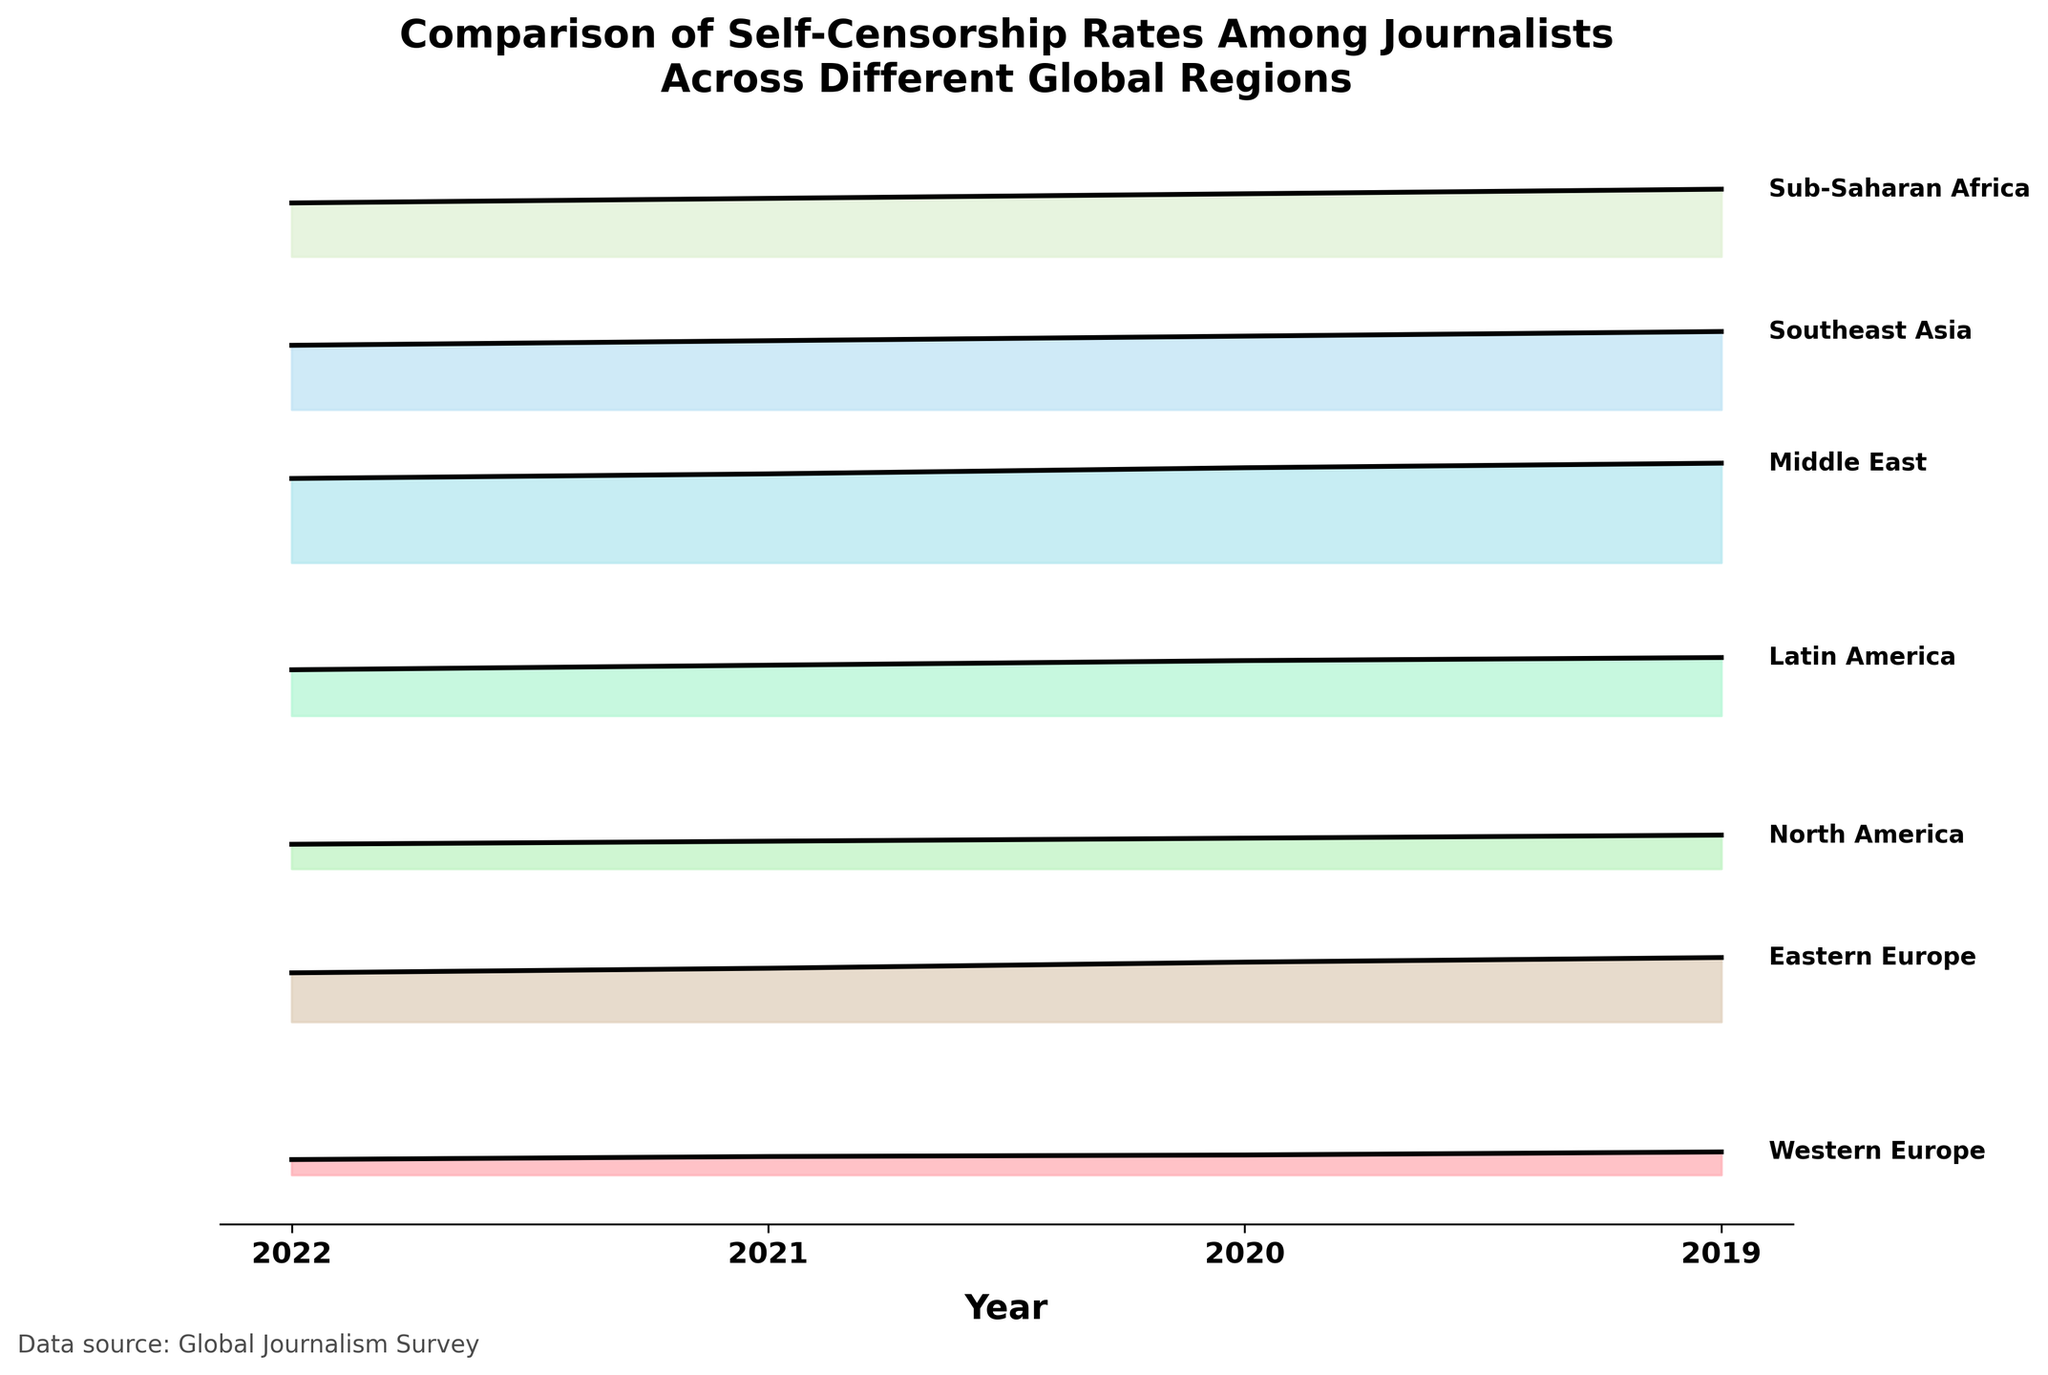what is the title of the figure? The title is usually found at the top of the figure. Here it says "Comparison of Self-Censorship Rates Among Journalists Across Different Global Regions."
Answer: Comparison of Self-Censorship Rates Among Journalists Across Different Global Regions How many years of data are displayed in the plot? The x-axis labels show the years. Counting these labels will give the number of years displayed. The years shown are 2019, 2020, 2021, and 2022.
Answer: 4 Which region has the highest self-censorship rate in 2022? Looking at the highest point in 2022 on the right side of the plot, the color-coded ridgeline with the highest elevation represents the Middle East.
Answer: Middle East How does the self-censorship rate in Western Europe change from 2019 to 2022? Following the ridgeline for Western Europe, the self-censorship rate starts at 0.10 in 2019 and increases each year to 0.15 in 2022.
Answer: It increases Which regions show an increasing trend in self-censorship rate over the years? Observing the slopes of the ridgelines, Western Europe, North America, Latin America, Southeast Asia, and Sub-Saharan Africa show increasing trends as their rates rise year by year.
Answer: Western Europe, North America, Latin America, Southeast Asia, Sub-Saharan Africa Which region has the highest self-censorship rate overall across all years? The plot shows different color-coded ridgelines. The Middle East consistently has the highest elevation throughout the years from 2019 to 2022, indicating the highest self-censorship rates.
Answer: Middle East Between North America and Eastern Europe in 2019, which has a higher self-censorship rate? Check the ridgelines for North America and Eastern Europe at the position corresponding to 2019. North America's rate is lower at 0.16, while Eastern Europe's rate is higher at 0.32.
Answer: Eastern Europe What is the overall trend in self-censorship rates for Southeast Asia from 2019 to 2022? Following the ridgeline for Southeast Asia, the self-censorship rate increases steadily from 0.42 in 2019 to 0.51 in 2022.
Answer: Increasing Which region had the most significant increase in self-censorship rate from 2019 to 2022? Calculating the difference in rates between 2019 and 2022 for all regions, the Middle East increased from 0.55 to 0.65, a difference of 0.10. This is the highest increase observed.
Answer: Middle East How does the self-censorship rate compare between Latin America and Sub-Saharan Africa in 2021? Observe the ridgelines for Latin America and Sub-Saharan Africa at the year 2021. Latin America's rate is 0.36, and Sub-Saharan Africa's rate is 0.41. Sub-Saharan Africa has a higher rate.
Answer: Sub-Saharan Africa 